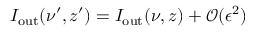Convert formula to latex. <formula><loc_0><loc_0><loc_500><loc_500>I _ { o u t } ( \nu ^ { \prime } , z ^ { \prime } ) = I _ { o u t } ( \nu , z ) + \mathcal { O } ( \epsilon ^ { 2 } )</formula> 